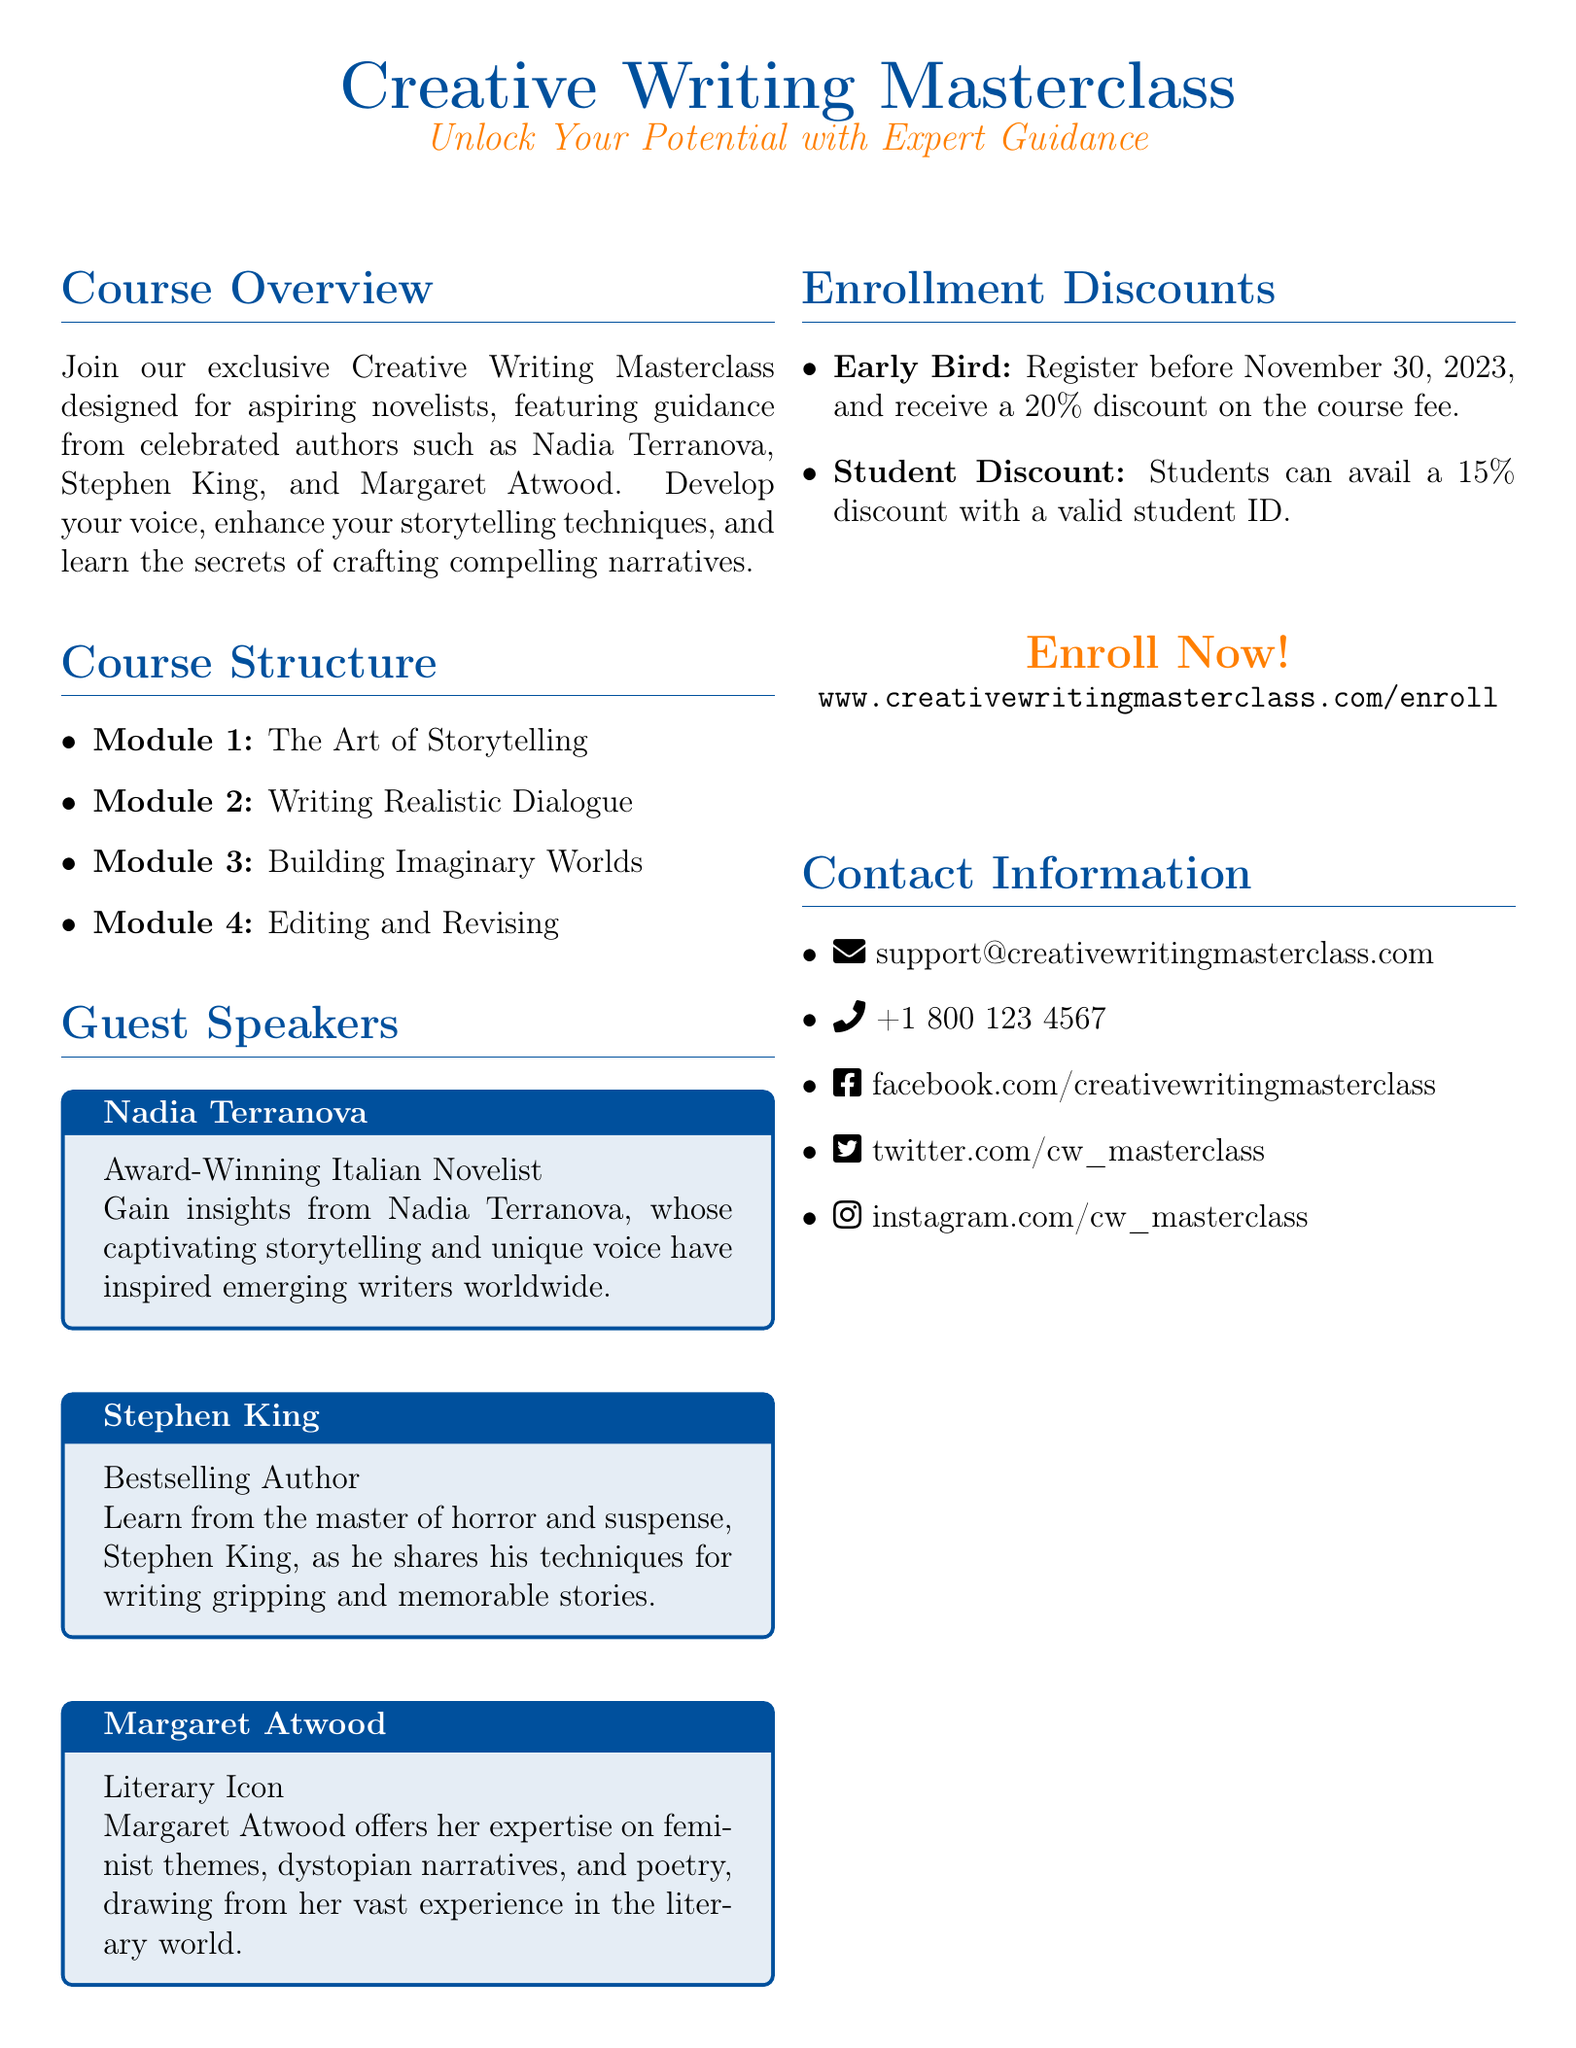What is the course title? The title of the course is prominently displayed at the top of the document.
Answer: Creative Writing Masterclass Who is the first guest speaker listed? The guest speakers are highlighted in tcolor boxes, with the first speaker mentioned at the top.
Answer: Nadia Terranova What discount is offered for early enrollment? The information on enrollment discounts details specific percentages for early registration.
Answer: 20% What are the four modules of the course? Each module is listed in the course structure section of the document.
Answer: The Art of Storytelling, Writing Realistic Dialogue, Building Imaginary Worlds, Editing and Revising Which social media platform is mentioned? The contact information section lists various social media handles associated with the masterclass.
Answer: Facebook How can students avail a discount? The document outlines specific eligibility criteria for discounts, focusing on student ID verification.
Answer: Valid student ID What theme does Margaret Atwood specialize in? The description of Margaret Atwood includes her areas of expertise relevant to the course.
Answer: Feminist themes, dystopian narratives, and poetry What is the contact email provided? The contact information contains the support email for inquiries related to the masterclass.
Answer: support@creativewritingmasterclass.com 